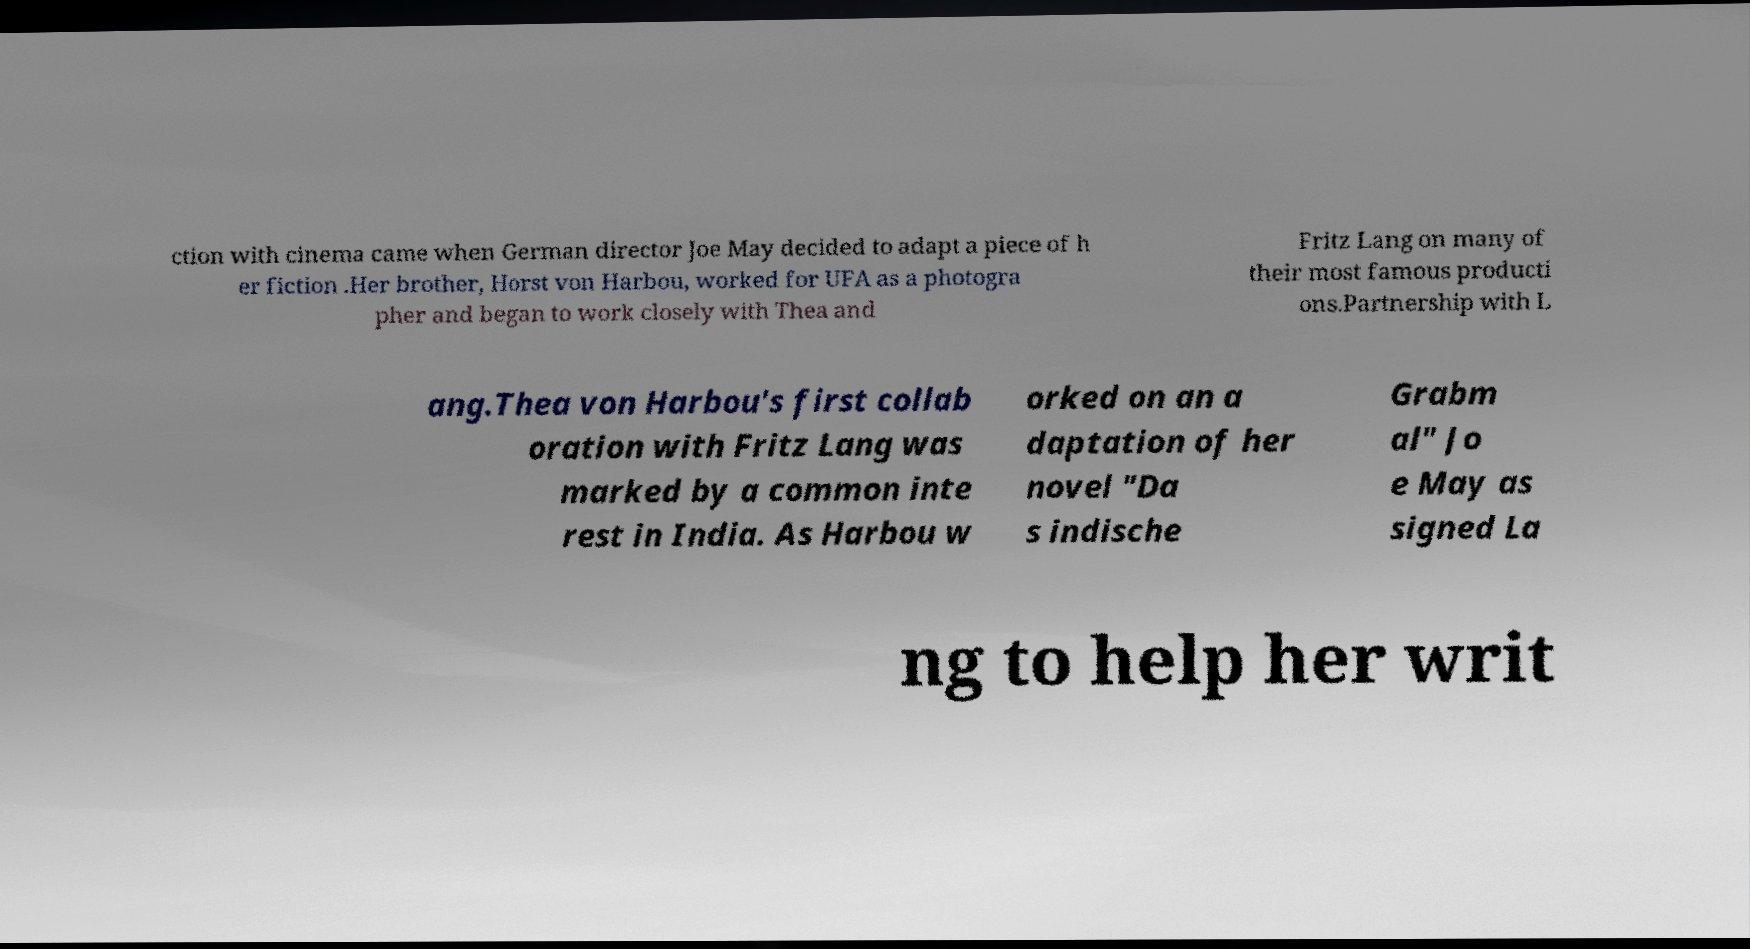Could you assist in decoding the text presented in this image and type it out clearly? ction with cinema came when German director Joe May decided to adapt a piece of h er fiction .Her brother, Horst von Harbou, worked for UFA as a photogra pher and began to work closely with Thea and Fritz Lang on many of their most famous producti ons.Partnership with L ang.Thea von Harbou's first collab oration with Fritz Lang was marked by a common inte rest in India. As Harbou w orked on an a daptation of her novel "Da s indische Grabm al" Jo e May as signed La ng to help her writ 